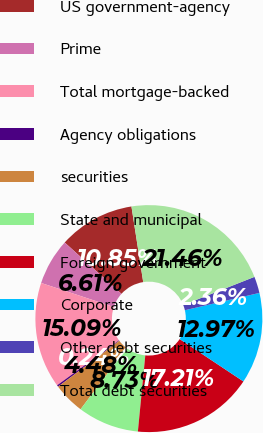<chart> <loc_0><loc_0><loc_500><loc_500><pie_chart><fcel>US government-agency<fcel>Prime<fcel>Total mortgage-backed<fcel>Agency obligations<fcel>securities<fcel>State and municipal<fcel>Foreign government<fcel>Corporate<fcel>Other debt securities<fcel>Total debt securities<nl><fcel>10.85%<fcel>6.61%<fcel>15.09%<fcel>0.24%<fcel>4.48%<fcel>8.73%<fcel>17.21%<fcel>12.97%<fcel>2.36%<fcel>21.46%<nl></chart> 